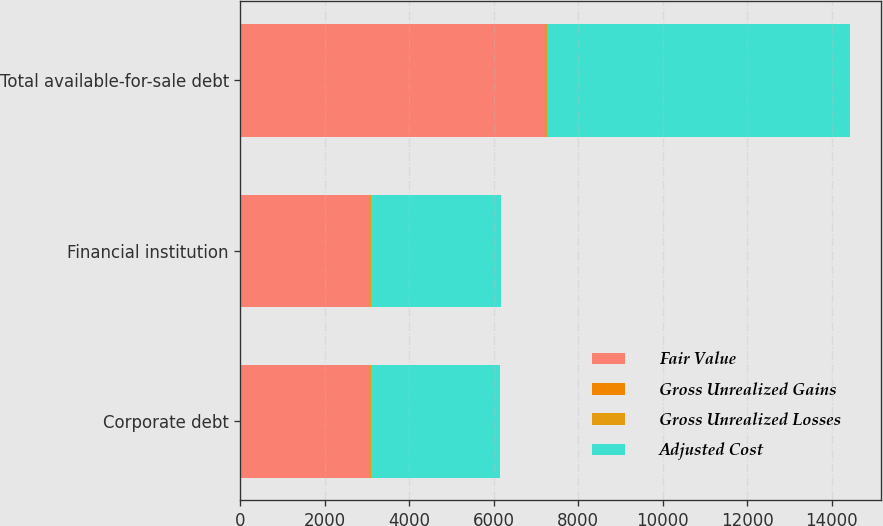Convert chart to OTSL. <chart><loc_0><loc_0><loc_500><loc_500><stacked_bar_chart><ecel><fcel>Corporate debt<fcel>Financial institution<fcel>Total available-for-sale debt<nl><fcel>Fair Value<fcel>3068<fcel>3076<fcel>7213<nl><fcel>Gross Unrealized Gains<fcel>2<fcel>3<fcel>6<nl><fcel>Gross Unrealized Losses<fcel>28<fcel>11<fcel>48<nl><fcel>Adjusted Cost<fcel>3042<fcel>3068<fcel>7171<nl></chart> 